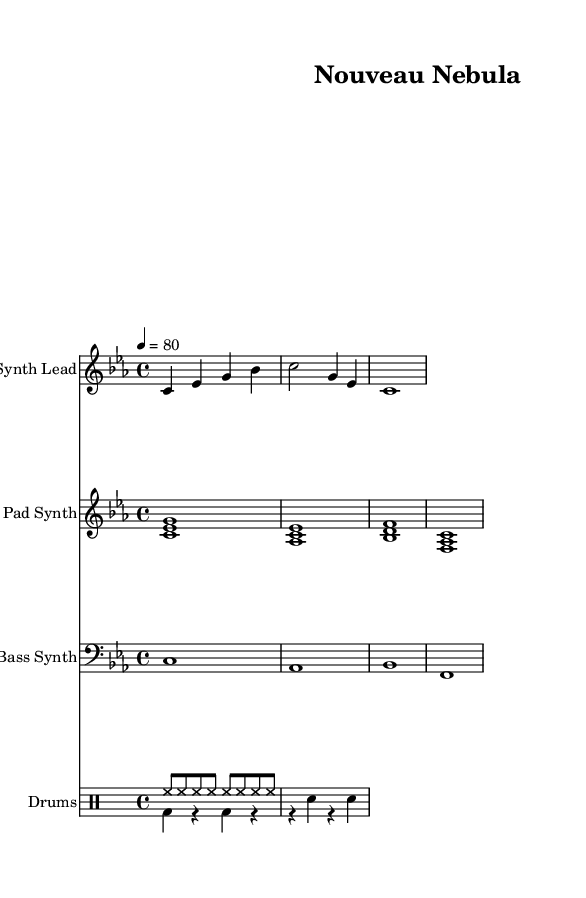What is the key signature of this music? The key signature is indicated by the absence of sharps or flats on the staff, which signals that the piece is in C minor (not C major). In music notation, a key signature without any accidentals reflects the corresponding diatonic scale.
Answer: C minor What is the time signature of this music? The time signature is represented at the beginning of the score, where the notation 4/4 indicates four beats in each measure with a quarter note receiving one beat. This is confirmed by counting the note values within the measures.
Answer: 4/4 What is the tempo of this piece? The tempo is given by the marking that indicates the speed of the music, specifically at the beginning where it shows 4 equals 80. This reflects the number of beats per minute, denoting that there are 80 quarter note beats in one minute.
Answer: 80 How many measures are in the Synth Lead? The Synth Lead has a total of three measures indicated by the vertical lines separating each group of notes in the staff. Each measure’s boundaries are clearly denoted, allowing for a count of the measures present.
Answer: 3 What type of instruments are used in this composition? The instruments used are clearly labeled in the score with their respective names: "Synth Lead," "Pad Synth," "Bass Synth," and "Drums." These labels are typically placed above the staves, identifying the different instrumental parts for performance.
Answer: Synth Lead, Pad Synth, Bass Synth, Drums How many distinct drum patterns are presented? There are two drum patterns specified: the "drumPatternUp," which consists of a hi-hat pattern, and the "drumPatternDown," which includes kick and snare components. Evaluating the drum staves reveals these two separate rhythm patterns for performance.
Answer: 2 